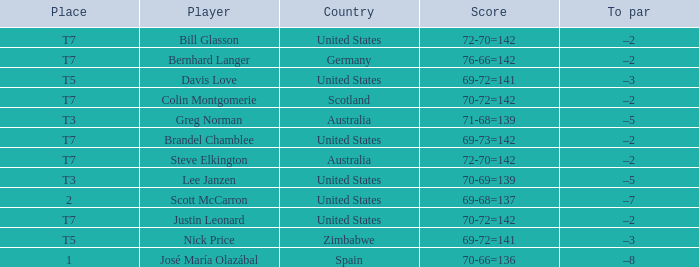Name the Player who has a Place of t7 in Country of united states? Brandel Chamblee, Bill Glasson, Justin Leonard. 